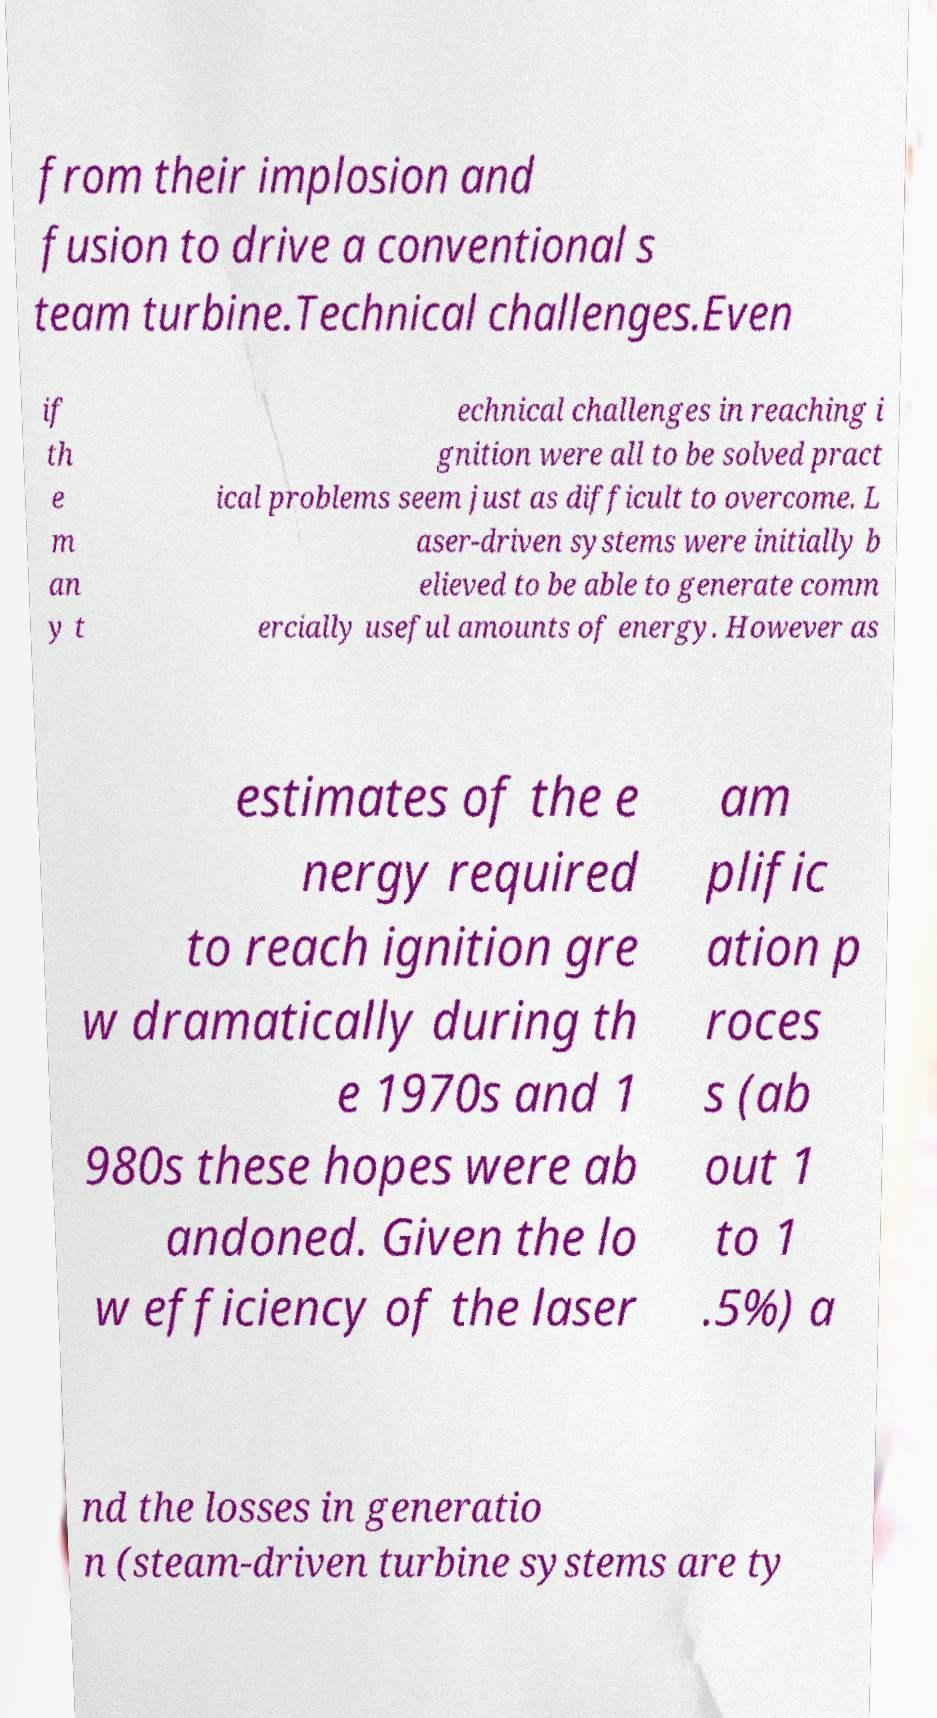Please read and relay the text visible in this image. What does it say? from their implosion and fusion to drive a conventional s team turbine.Technical challenges.Even if th e m an y t echnical challenges in reaching i gnition were all to be solved pract ical problems seem just as difficult to overcome. L aser-driven systems were initially b elieved to be able to generate comm ercially useful amounts of energy. However as estimates of the e nergy required to reach ignition gre w dramatically during th e 1970s and 1 980s these hopes were ab andoned. Given the lo w efficiency of the laser am plific ation p roces s (ab out 1 to 1 .5%) a nd the losses in generatio n (steam-driven turbine systems are ty 